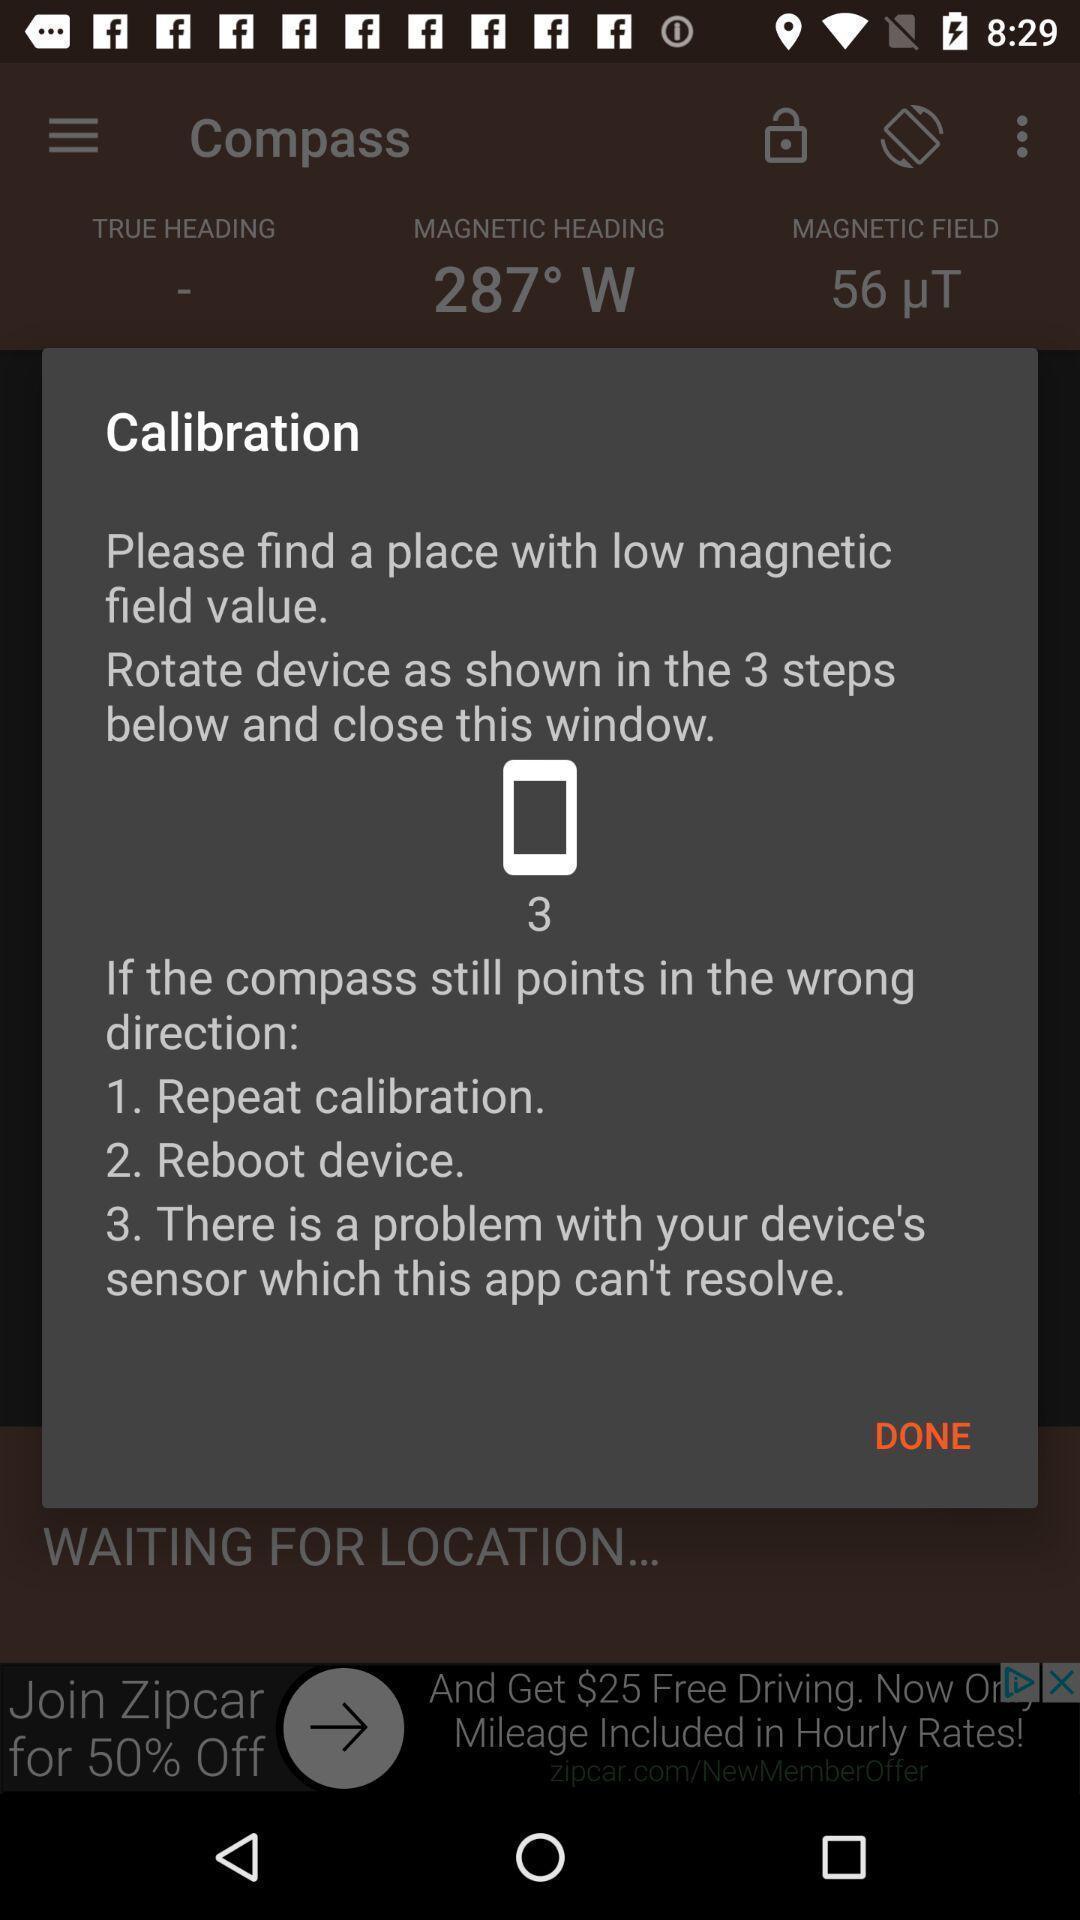What can you discern from this picture? Pop-up shows calibration details. 